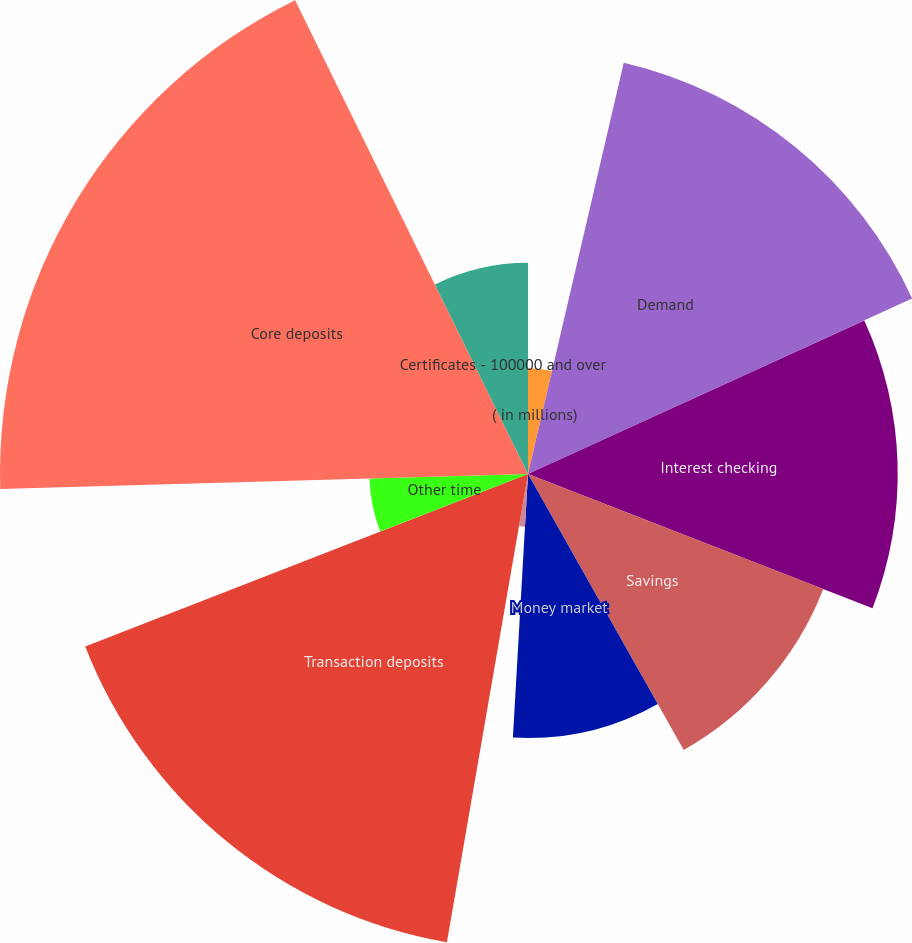<chart> <loc_0><loc_0><loc_500><loc_500><pie_chart><fcel>( in millions)<fcel>Demand<fcel>Interest checking<fcel>Savings<fcel>Money market<fcel>Foreign office<fcel>Transaction deposits<fcel>Other time<fcel>Core deposits<fcel>Certificates - 100000 and over<nl><fcel>3.64%<fcel>14.54%<fcel>12.73%<fcel>10.91%<fcel>9.09%<fcel>1.82%<fcel>16.36%<fcel>5.46%<fcel>18.18%<fcel>7.27%<nl></chart> 